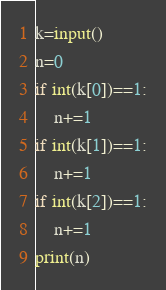Convert code to text. <code><loc_0><loc_0><loc_500><loc_500><_Python_>k=input()
n=0
if int(k[0])==1:
    n+=1
if int(k[1])==1:
    n+=1
if int(k[2])==1:
    n+=1
print(n)
</code> 